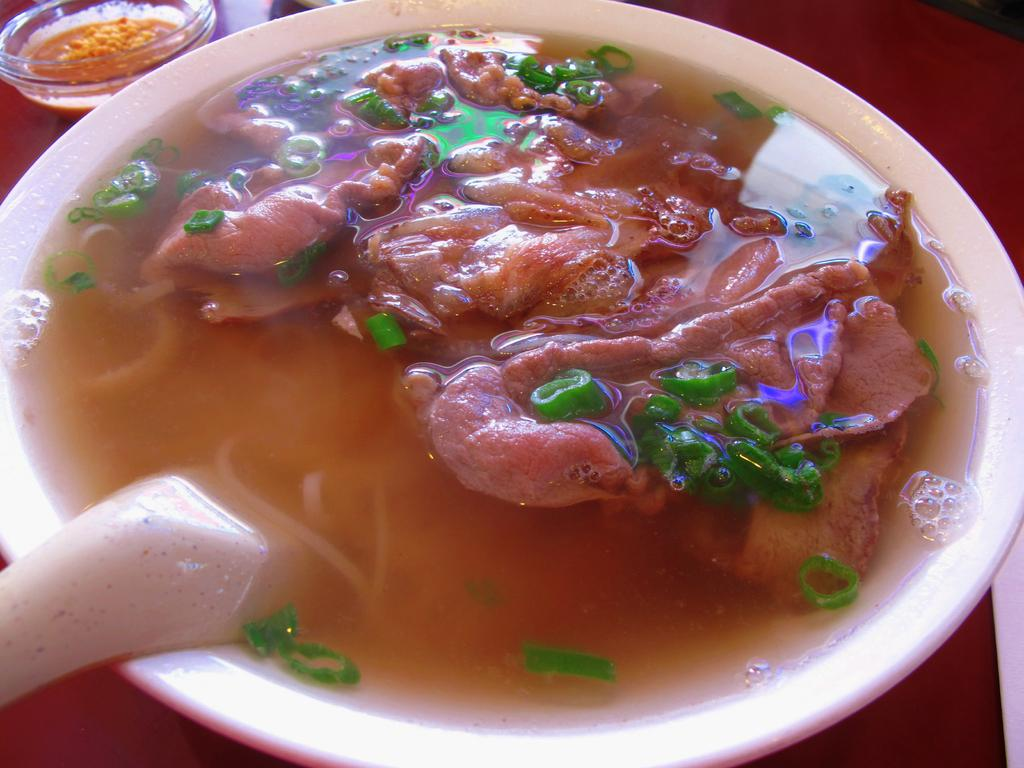What is present in the image related to eating? There is food in the image, and there is a spoon in the bowl. Can you describe the spoon in the bowl? The spoon is in the bowl, which suggests it is being used to eat the food. How much money is being spent on the food in the image? There is no information about the cost of the food in the image, so it cannot be determined. 